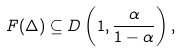Convert formula to latex. <formula><loc_0><loc_0><loc_500><loc_500>F ( \Delta ) \subseteq D \left ( 1 , \frac { \alpha } { 1 - \alpha } \right ) ,</formula> 